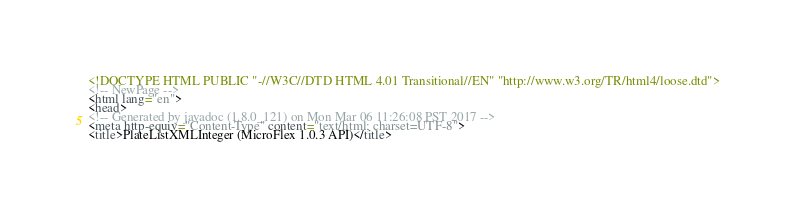<code> <loc_0><loc_0><loc_500><loc_500><_HTML_><!DOCTYPE HTML PUBLIC "-//W3C//DTD HTML 4.01 Transitional//EN" "http://www.w3.org/TR/html4/loose.dtd">
<!-- NewPage -->
<html lang="en">
<head>
<!-- Generated by javadoc (1.8.0_121) on Mon Mar 06 11:26:08 PST 2017 -->
<meta http-equiv="Content-Type" content="text/html; charset=UTF-8">
<title>PlateListXMLInteger (MicroFlex 1.0.3 API)</title></code> 